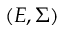<formula> <loc_0><loc_0><loc_500><loc_500>( E , \Sigma )</formula> 